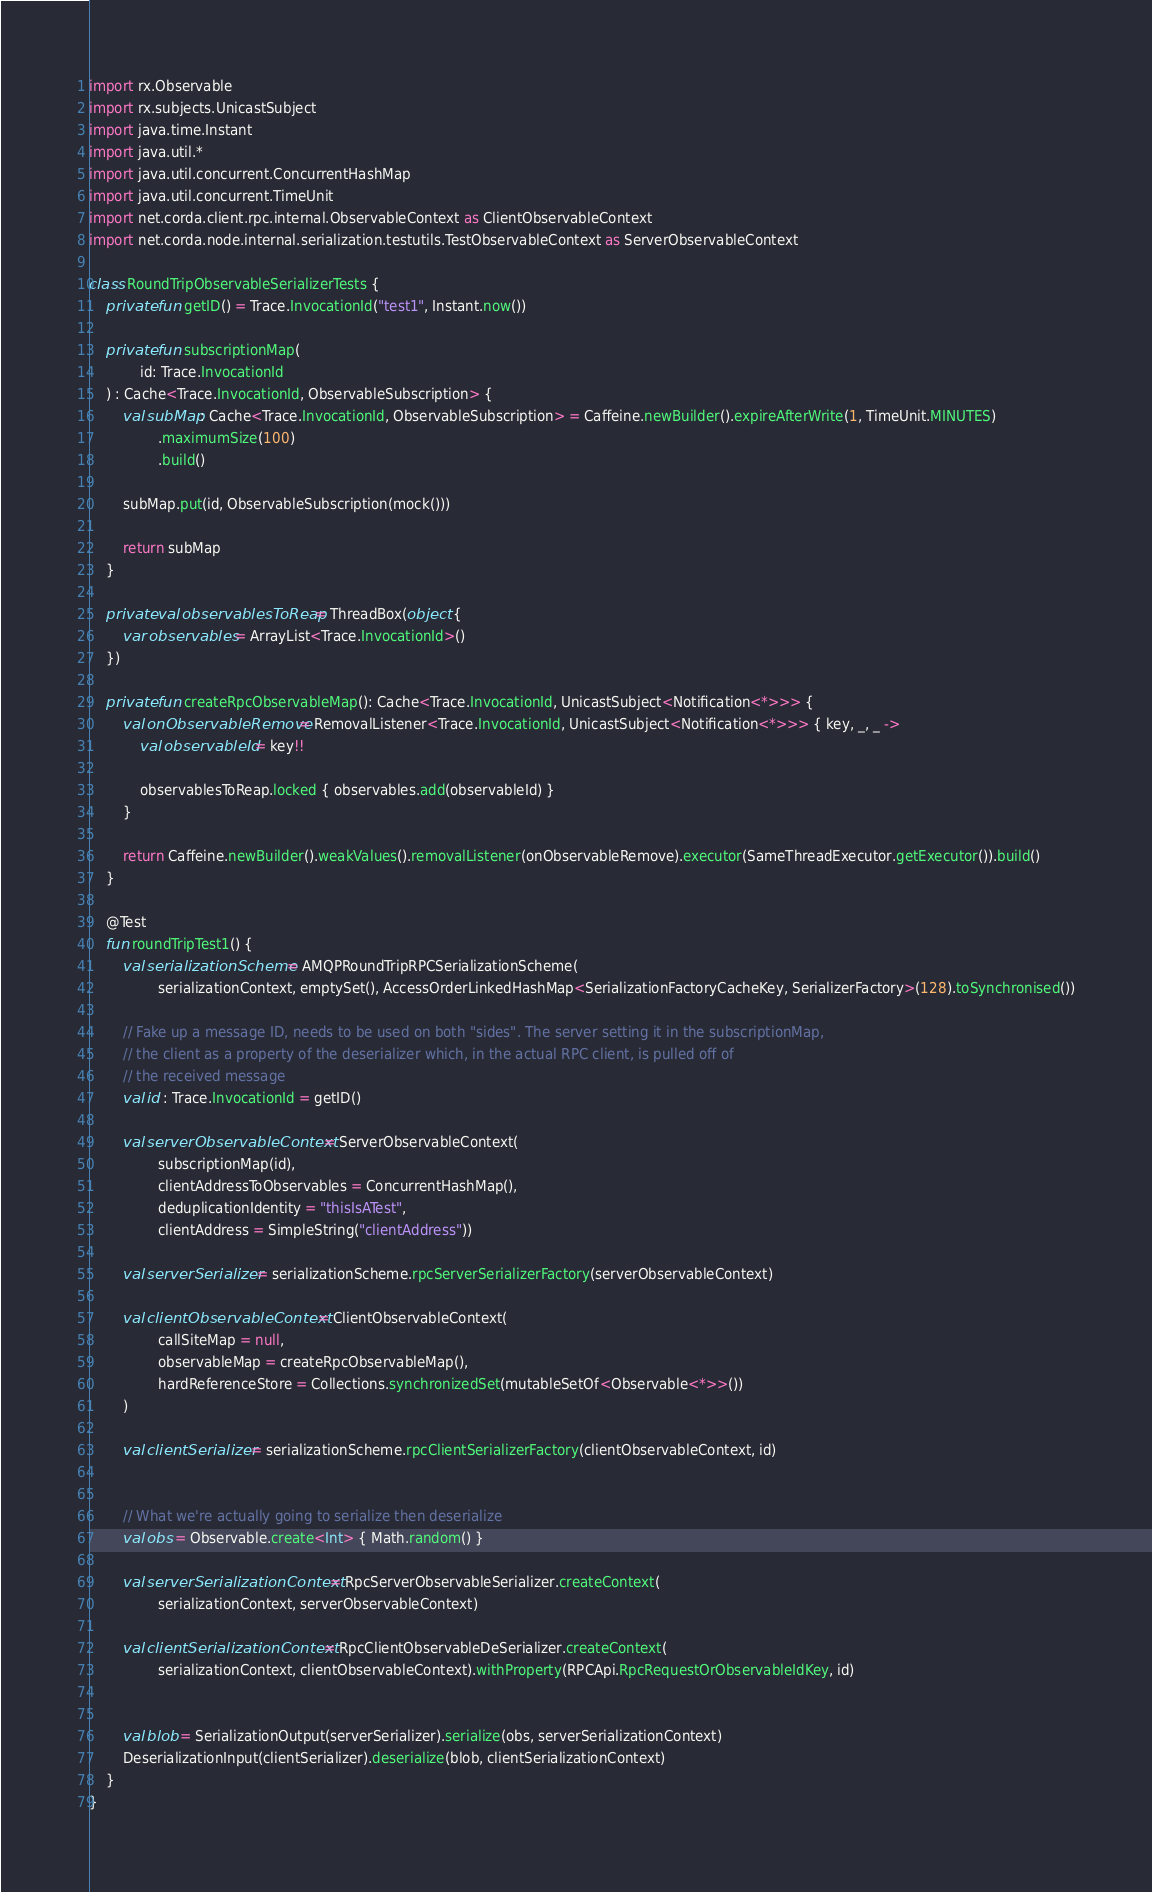Convert code to text. <code><loc_0><loc_0><loc_500><loc_500><_Kotlin_>import rx.Observable
import rx.subjects.UnicastSubject
import java.time.Instant
import java.util.*
import java.util.concurrent.ConcurrentHashMap
import java.util.concurrent.TimeUnit
import net.corda.client.rpc.internal.ObservableContext as ClientObservableContext
import net.corda.node.internal.serialization.testutils.TestObservableContext as ServerObservableContext

class RoundTripObservableSerializerTests {
    private fun getID() = Trace.InvocationId("test1", Instant.now())

    private fun subscriptionMap(
            id: Trace.InvocationId
    ) : Cache<Trace.InvocationId, ObservableSubscription> {
        val subMap: Cache<Trace.InvocationId, ObservableSubscription> = Caffeine.newBuilder().expireAfterWrite(1, TimeUnit.MINUTES)
                .maximumSize(100)
                .build()

        subMap.put(id, ObservableSubscription(mock()))

        return subMap
    }

    private val observablesToReap = ThreadBox(object {
        var observables = ArrayList<Trace.InvocationId>()
    })

    private fun createRpcObservableMap(): Cache<Trace.InvocationId, UnicastSubject<Notification<*>>> {
        val onObservableRemove = RemovalListener<Trace.InvocationId, UnicastSubject<Notification<*>>> { key, _, _ ->
            val observableId = key!!

            observablesToReap.locked { observables.add(observableId) }
        }

        return Caffeine.newBuilder().weakValues().removalListener(onObservableRemove).executor(SameThreadExecutor.getExecutor()).build()
    }

    @Test
    fun roundTripTest1() {
        val serializationScheme = AMQPRoundTripRPCSerializationScheme(
                serializationContext, emptySet(), AccessOrderLinkedHashMap<SerializationFactoryCacheKey, SerializerFactory>(128).toSynchronised())

        // Fake up a message ID, needs to be used on both "sides". The server setting it in the subscriptionMap,
        // the client as a property of the deserializer which, in the actual RPC client, is pulled off of
        // the received message
        val id : Trace.InvocationId = getID()

        val serverObservableContext = ServerObservableContext(
                subscriptionMap(id),
                clientAddressToObservables = ConcurrentHashMap(),
                deduplicationIdentity = "thisIsATest",
                clientAddress = SimpleString("clientAddress"))

        val serverSerializer = serializationScheme.rpcServerSerializerFactory(serverObservableContext)

        val clientObservableContext = ClientObservableContext(
                callSiteMap = null,
                observableMap = createRpcObservableMap(),
                hardReferenceStore = Collections.synchronizedSet(mutableSetOf<Observable<*>>())
        )

        val clientSerializer = serializationScheme.rpcClientSerializerFactory(clientObservableContext, id)


        // What we're actually going to serialize then deserialize
        val obs = Observable.create<Int> { Math.random() }

        val serverSerializationContext = RpcServerObservableSerializer.createContext(
                serializationContext, serverObservableContext)

        val clientSerializationContext = RpcClientObservableDeSerializer.createContext(
                serializationContext, clientObservableContext).withProperty(RPCApi.RpcRequestOrObservableIdKey, id)


        val blob = SerializationOutput(serverSerializer).serialize(obs, serverSerializationContext)
        DeserializationInput(clientSerializer).deserialize(blob, clientSerializationContext)
    }
}
</code> 